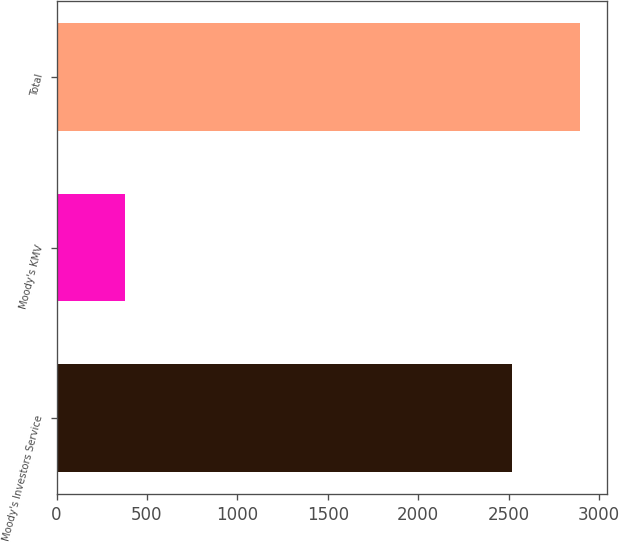<chart> <loc_0><loc_0><loc_500><loc_500><bar_chart><fcel>Moody's Investors Service<fcel>Moody's KMV<fcel>Total<nl><fcel>2519<fcel>377<fcel>2896<nl></chart> 